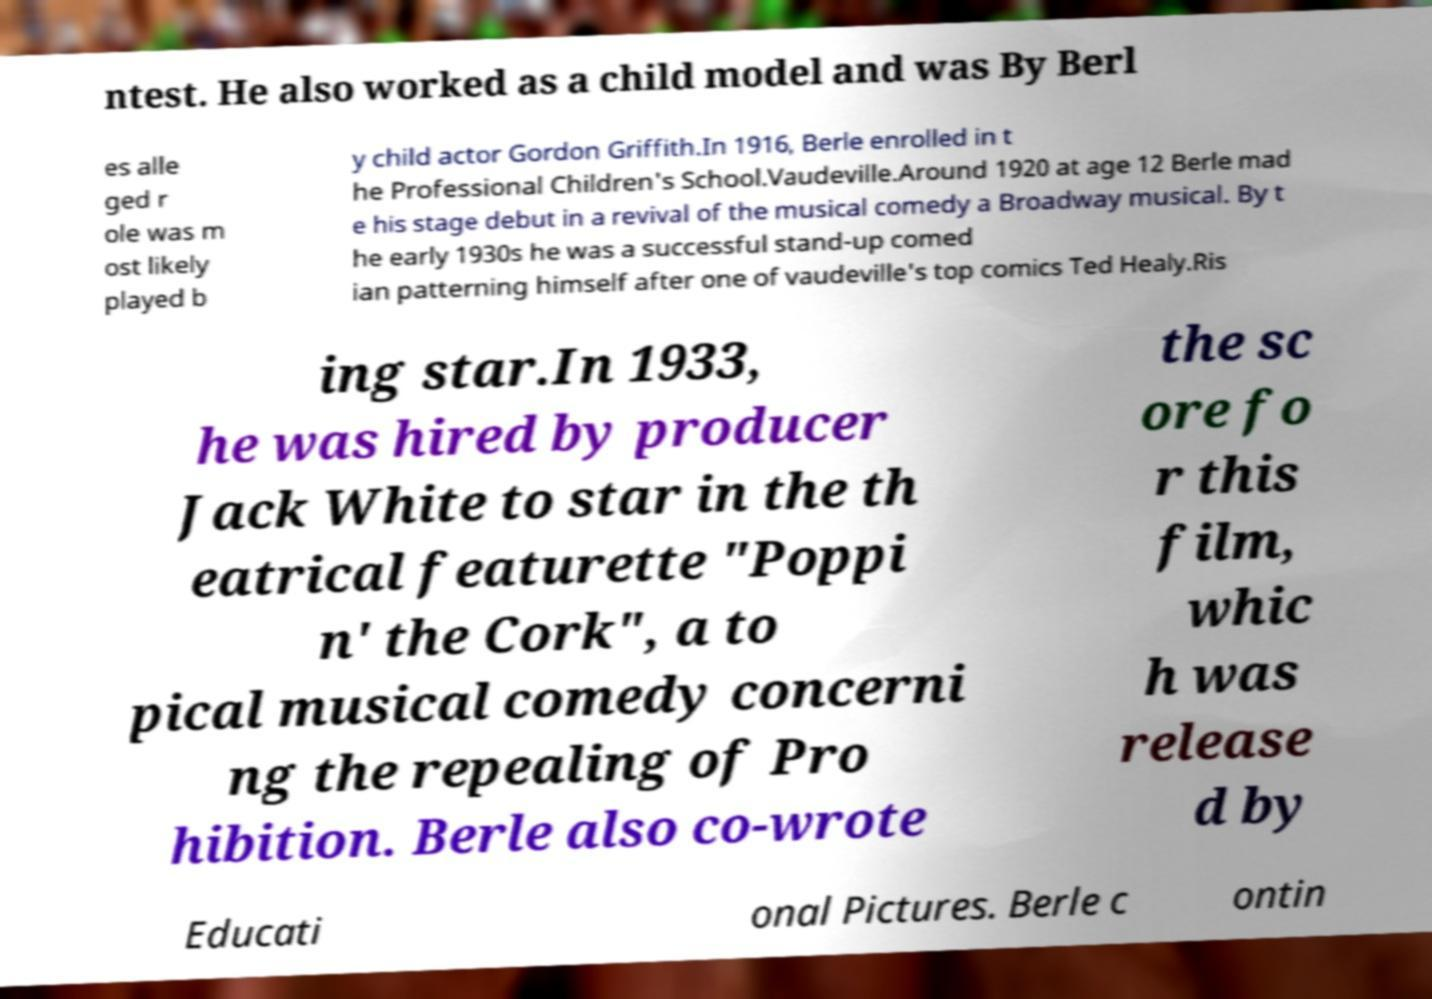For documentation purposes, I need the text within this image transcribed. Could you provide that? ntest. He also worked as a child model and was By Berl es alle ged r ole was m ost likely played b y child actor Gordon Griffith.In 1916, Berle enrolled in t he Professional Children's School.Vaudeville.Around 1920 at age 12 Berle mad e his stage debut in a revival of the musical comedy a Broadway musical. By t he early 1930s he was a successful stand-up comed ian patterning himself after one of vaudeville's top comics Ted Healy.Ris ing star.In 1933, he was hired by producer Jack White to star in the th eatrical featurette "Poppi n' the Cork", a to pical musical comedy concerni ng the repealing of Pro hibition. Berle also co-wrote the sc ore fo r this film, whic h was release d by Educati onal Pictures. Berle c ontin 